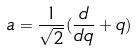<formula> <loc_0><loc_0><loc_500><loc_500>a = \frac { 1 } { \sqrt { 2 } } ( \frac { d } { d q } + q )</formula> 